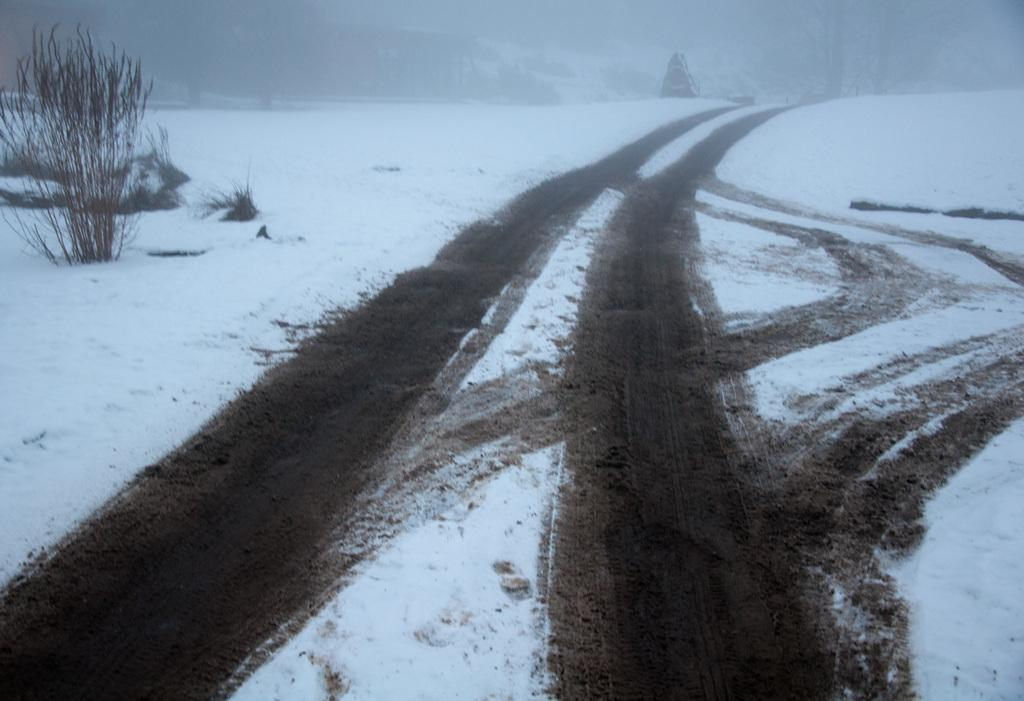What is covering the ground in the image? There is snow on the ground. What evidence suggests that vehicles have been in the area? There are marks of tires on the ground. What type of vegetation can be seen in the image? There are plants visible in the image. What can be seen in the distance in the background? There are trees in the background. How would you describe the clarity of the background in the image? The background appears blurry. How many sticks are being used to prop up the hydrant in the image? There is no hydrant or sticks present in the image. 